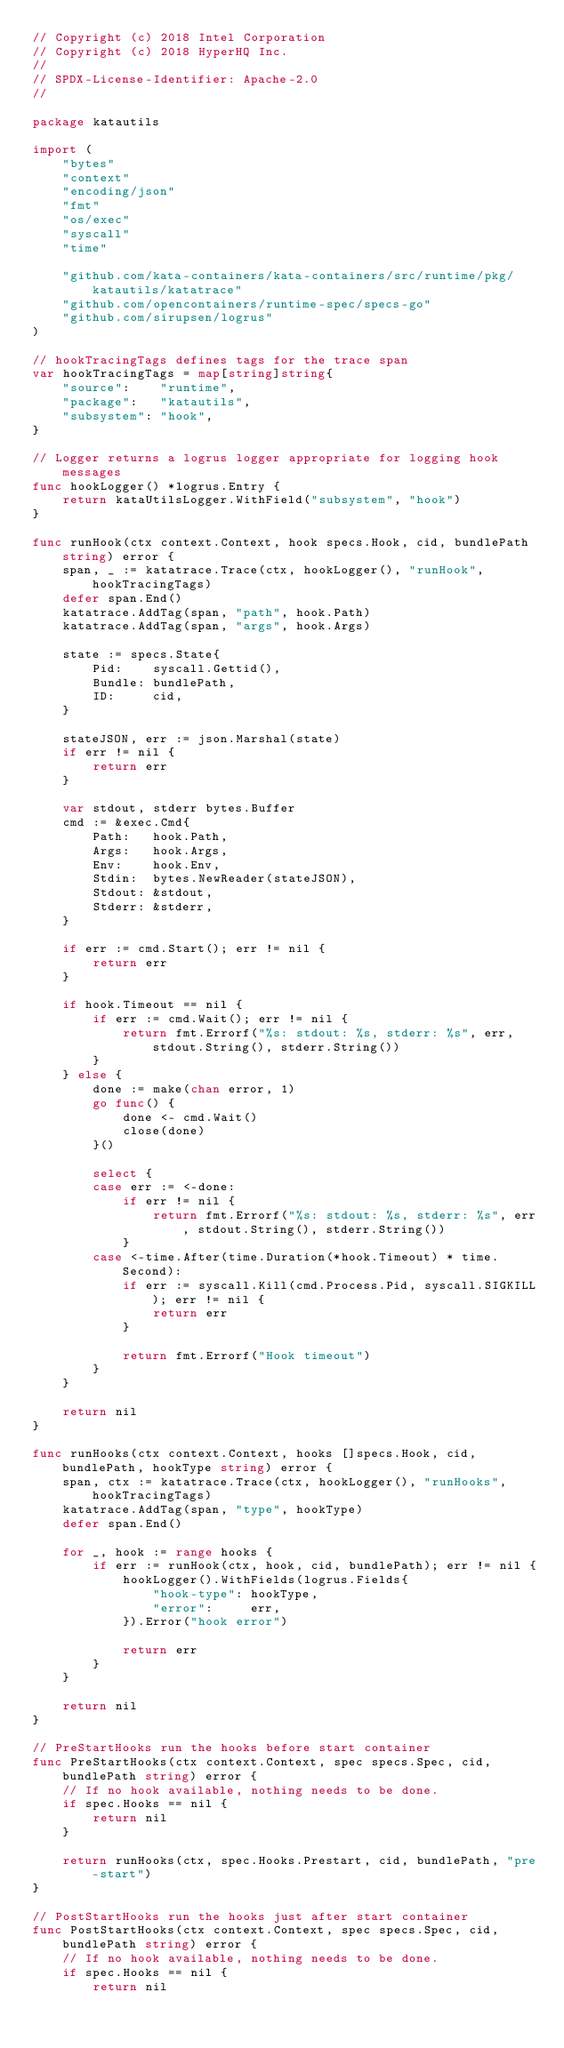<code> <loc_0><loc_0><loc_500><loc_500><_Go_>// Copyright (c) 2018 Intel Corporation
// Copyright (c) 2018 HyperHQ Inc.
//
// SPDX-License-Identifier: Apache-2.0
//

package katautils

import (
	"bytes"
	"context"
	"encoding/json"
	"fmt"
	"os/exec"
	"syscall"
	"time"

	"github.com/kata-containers/kata-containers/src/runtime/pkg/katautils/katatrace"
	"github.com/opencontainers/runtime-spec/specs-go"
	"github.com/sirupsen/logrus"
)

// hookTracingTags defines tags for the trace span
var hookTracingTags = map[string]string{
	"source":    "runtime",
	"package":   "katautils",
	"subsystem": "hook",
}

// Logger returns a logrus logger appropriate for logging hook messages
func hookLogger() *logrus.Entry {
	return kataUtilsLogger.WithField("subsystem", "hook")
}

func runHook(ctx context.Context, hook specs.Hook, cid, bundlePath string) error {
	span, _ := katatrace.Trace(ctx, hookLogger(), "runHook", hookTracingTags)
	defer span.End()
	katatrace.AddTag(span, "path", hook.Path)
	katatrace.AddTag(span, "args", hook.Args)

	state := specs.State{
		Pid:    syscall.Gettid(),
		Bundle: bundlePath,
		ID:     cid,
	}

	stateJSON, err := json.Marshal(state)
	if err != nil {
		return err
	}

	var stdout, stderr bytes.Buffer
	cmd := &exec.Cmd{
		Path:   hook.Path,
		Args:   hook.Args,
		Env:    hook.Env,
		Stdin:  bytes.NewReader(stateJSON),
		Stdout: &stdout,
		Stderr: &stderr,
	}

	if err := cmd.Start(); err != nil {
		return err
	}

	if hook.Timeout == nil {
		if err := cmd.Wait(); err != nil {
			return fmt.Errorf("%s: stdout: %s, stderr: %s", err, stdout.String(), stderr.String())
		}
	} else {
		done := make(chan error, 1)
		go func() {
			done <- cmd.Wait()
			close(done)
		}()

		select {
		case err := <-done:
			if err != nil {
				return fmt.Errorf("%s: stdout: %s, stderr: %s", err, stdout.String(), stderr.String())
			}
		case <-time.After(time.Duration(*hook.Timeout) * time.Second):
			if err := syscall.Kill(cmd.Process.Pid, syscall.SIGKILL); err != nil {
				return err
			}

			return fmt.Errorf("Hook timeout")
		}
	}

	return nil
}

func runHooks(ctx context.Context, hooks []specs.Hook, cid, bundlePath, hookType string) error {
	span, ctx := katatrace.Trace(ctx, hookLogger(), "runHooks", hookTracingTags)
	katatrace.AddTag(span, "type", hookType)
	defer span.End()

	for _, hook := range hooks {
		if err := runHook(ctx, hook, cid, bundlePath); err != nil {
			hookLogger().WithFields(logrus.Fields{
				"hook-type": hookType,
				"error":     err,
			}).Error("hook error")

			return err
		}
	}

	return nil
}

// PreStartHooks run the hooks before start container
func PreStartHooks(ctx context.Context, spec specs.Spec, cid, bundlePath string) error {
	// If no hook available, nothing needs to be done.
	if spec.Hooks == nil {
		return nil
	}

	return runHooks(ctx, spec.Hooks.Prestart, cid, bundlePath, "pre-start")
}

// PostStartHooks run the hooks just after start container
func PostStartHooks(ctx context.Context, spec specs.Spec, cid, bundlePath string) error {
	// If no hook available, nothing needs to be done.
	if spec.Hooks == nil {
		return nil</code> 